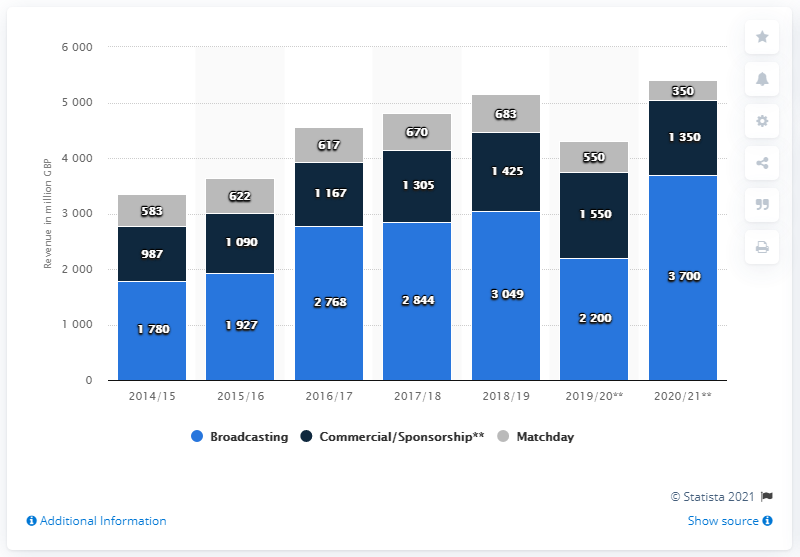Draw attention to some important aspects in this diagram. On matchdays, an estimated 683 British pounds are generated. 